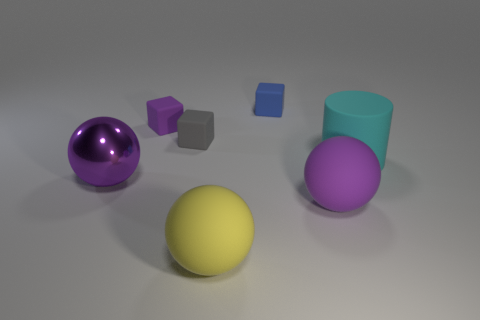What number of tiny objects are either blue spheres or yellow objects?
Give a very brief answer. 0. How many purple balls are on the right side of the metal thing?
Ensure brevity in your answer.  1. Is the number of tiny gray blocks that are on the right side of the big cyan thing greater than the number of big cylinders?
Offer a very short reply. No. What shape is the large purple object that is the same material as the cyan cylinder?
Your answer should be compact. Sphere. There is a large matte object to the left of the large purple sphere that is on the right side of the purple shiny sphere; what is its color?
Offer a very short reply. Yellow. Does the yellow matte thing have the same shape as the small gray object?
Offer a terse response. No. There is a small purple thing that is the same shape as the tiny blue matte thing; what material is it?
Offer a very short reply. Rubber. Are there any tiny purple rubber blocks in front of the purple object that is in front of the big purple metallic sphere on the left side of the yellow matte sphere?
Keep it short and to the point. No. Do the big yellow matte thing and the big purple thing that is to the right of the shiny sphere have the same shape?
Your answer should be very brief. Yes. Is there anything else that is the same color as the large shiny thing?
Your response must be concise. Yes. 